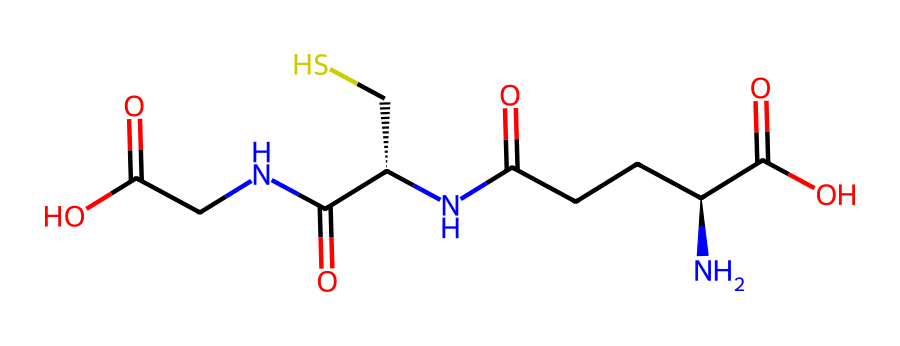What is the primary functional group present in glutathione? Glutathione has a thiol (-SH) functional group present due to the sulfur atom bonded to a hydrogen atom. This group is crucial for its antioxidant properties.
Answer: thiol How many carbon atoms are present in glutathione? By counting the carbon atoms in the SMILES representation, we can see that there are a total of 9 carbon atoms in the glutathione structure.
Answer: 9 What is the total number of nitrogen atoms in glutathione? The SMILES shows that there are 3 nitrogen atoms in the molecule, which can be counted by identifying each 'N' in the structure.
Answer: 3 What type of compound is glutathione classified as? Glutathione is classified as a tripeptide, indicating it is composed of three amino acids linked by peptide bonds.
Answer: tripeptide How does the sulfur in glutathione contribute to its function? The sulfur atom in the thiol group of glutathione plays a critical role in redox reactions, allowing glutathione to donate electrons and scavenge free radicals effectively.
Answer: redox reactions What is the significance of the carboxylic acid groups in glutathione? The carboxylic acid groups in glutathione contribute to its overall polarity and solubility in water, which is essential for its biological function in cells.
Answer: polarity and solubility How many double bonds are indicated in the glutathione structure? By examining the SMILES, there is one double bond present in the carbonyl (C=O) groups, which can be identified in the structure.
Answer: 1 